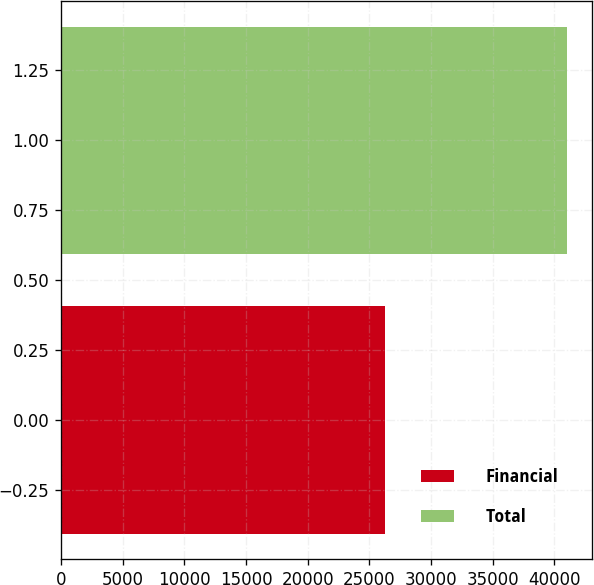<chart> <loc_0><loc_0><loc_500><loc_500><bar_chart><fcel>Financial<fcel>Total<nl><fcel>26256<fcel>40996<nl></chart> 